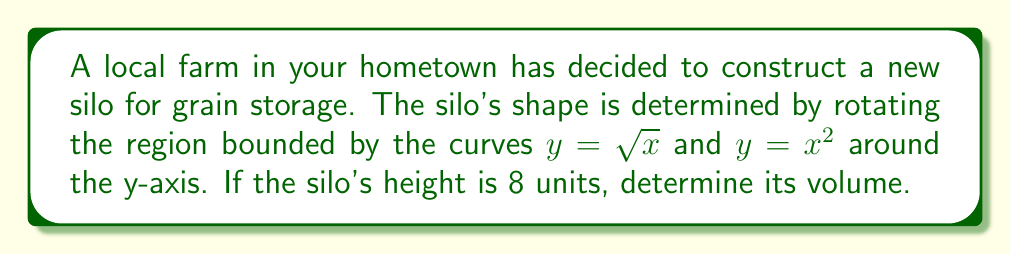Can you answer this question? To solve this problem, we'll use the shell method for finding the volume of a solid of revolution. The steps are as follows:

1) First, we need to determine the limits of integration. The curves intersect when:
   $\sqrt{x} = x^2$
   $x = x^4$
   $x(1-x^3) = 0$
   $x = 0$ or $x = 1$

   So, our limits of integration are from 0 to 1.

2) The shell method formula is:
   $$V = 2\pi \int_a^b r(x) h(x) dx$$
   where $r(x)$ is the distance from the axis of rotation (in this case, just $x$),
   and $h(x)$ is the height of each shell (in this case, $\sqrt{x} - x^2$).

3) Our integral becomes:
   $$V = 2\pi \int_0^1 x(\sqrt{x} - x^2) dx$$

4) Expanding the integrand:
   $$V = 2\pi \int_0^1 (x\sqrt{x} - x^3) dx$$

5) Substitute $u = \sqrt{x}$, so $x = u^2$ and $dx = 2u du$:
   $$V = 2\pi \int_0^1 (u^3 - u^6) 2u du$$
   $$V = 4\pi \int_0^1 (u^4 - u^7) du$$

6) Integrate:
   $$V = 4\pi [\frac{u^5}{5} - \frac{u^8}{8}]_0^1$$

7) Evaluate the integral:
   $$V = 4\pi (\frac{1}{5} - \frac{1}{8})$$
   $$V = 4\pi (\frac{8}{40} - \frac{5}{40})$$
   $$V = 4\pi (\frac{3}{40})$$
   $$V = \frac{3\pi}{10}$$

8) Since the height of the silo is 8 units, we need to scale our result:
   $$V_{final} = 8 * \frac{3\pi}{10} = \frac{12\pi}{5}$$
Answer: The volume of the silo is $\frac{12\pi}{5}$ cubic units. 